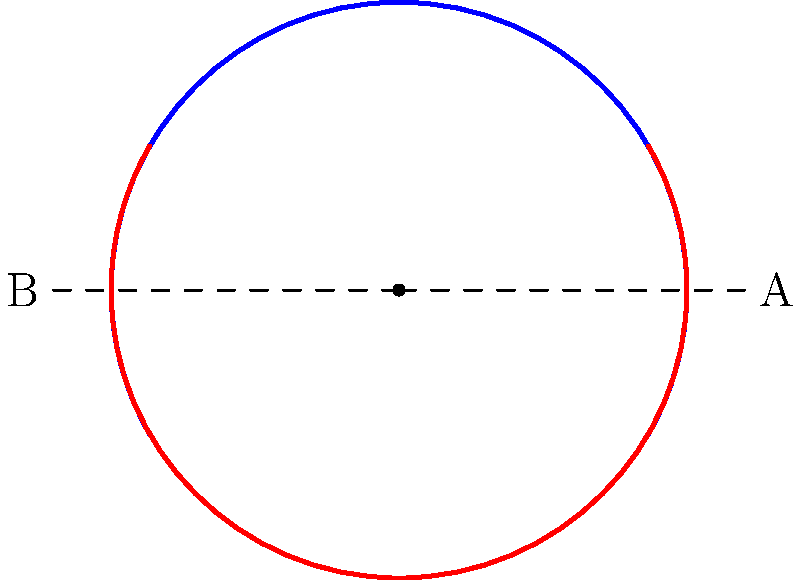In the context of animating facial expressions for emotional intelligence, consider the topological transformation between a happy face (blue arc) and a sad face (red arc). If we represent the mouth as an arc on a circle, what is the minimum number of intermediate states required to smoothly transform from the happy to the sad expression without breaking the continuity of the arc? To understand this transformation, let's follow these steps:

1. Observe that both the happy and sad expressions are represented as arcs on the same circle.

2. The happy expression (blue arc) starts at point A and ends at point B, moving counterclockwise.

3. The sad expression (red arc) starts at point B and ends at point A, also moving counterclockwise.

4. To transform from happy to sad continuously, we need to consider how the arc can move without breaking.

5. The key realization is that we can't simply "flip" the arc instantly, as this would break continuity.

6. Instead, we need to gradually rotate the arc through a full 360 degrees to reach the sad expression.

7. The minimum number of intermediate states would be one: a neutral expression where the arc forms a complete circle.

8. The transformation would proceed as follows:
   - Happy: Arc from A to B (counterclockwise)
   - Neutral: Complete circle
   - Sad: Arc from B to A (counterclockwise)

9. This ensures a smooth, continuous transformation without breaking the arc at any point.

Therefore, the minimum number of intermediate states required is 1 (the neutral expression).
Answer: 1 